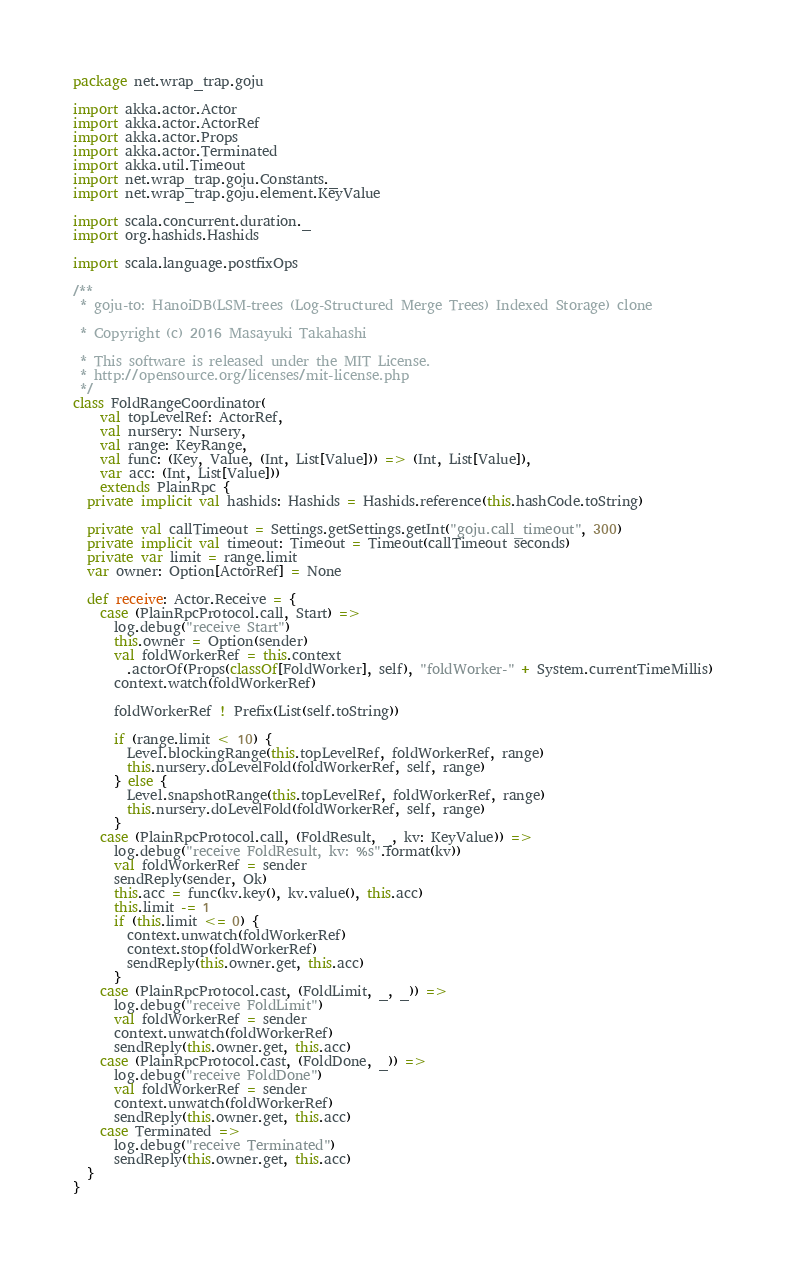<code> <loc_0><loc_0><loc_500><loc_500><_Scala_>package net.wrap_trap.goju

import akka.actor.Actor
import akka.actor.ActorRef
import akka.actor.Props
import akka.actor.Terminated
import akka.util.Timeout
import net.wrap_trap.goju.Constants._
import net.wrap_trap.goju.element.KeyValue

import scala.concurrent.duration._
import org.hashids.Hashids

import scala.language.postfixOps

/**
 * goju-to: HanoiDB(LSM-trees (Log-Structured Merge Trees) Indexed Storage) clone

 * Copyright (c) 2016 Masayuki Takahashi

 * This software is released under the MIT License.
 * http://opensource.org/licenses/mit-license.php
 */
class FoldRangeCoordinator(
    val topLevelRef: ActorRef,
    val nursery: Nursery,
    val range: KeyRange,
    val func: (Key, Value, (Int, List[Value])) => (Int, List[Value]),
    var acc: (Int, List[Value]))
    extends PlainRpc {
  private implicit val hashids: Hashids = Hashids.reference(this.hashCode.toString)

  private val callTimeout = Settings.getSettings.getInt("goju.call_timeout", 300)
  private implicit val timeout: Timeout = Timeout(callTimeout seconds)
  private var limit = range.limit
  var owner: Option[ActorRef] = None

  def receive: Actor.Receive = {
    case (PlainRpcProtocol.call, Start) =>
      log.debug("receive Start")
      this.owner = Option(sender)
      val foldWorkerRef = this.context
        .actorOf(Props(classOf[FoldWorker], self), "foldWorker-" + System.currentTimeMillis)
      context.watch(foldWorkerRef)

      foldWorkerRef ! Prefix(List(self.toString))

      if (range.limit < 10) {
        Level.blockingRange(this.topLevelRef, foldWorkerRef, range)
        this.nursery.doLevelFold(foldWorkerRef, self, range)
      } else {
        Level.snapshotRange(this.topLevelRef, foldWorkerRef, range)
        this.nursery.doLevelFold(foldWorkerRef, self, range)
      }
    case (PlainRpcProtocol.call, (FoldResult, _, kv: KeyValue)) =>
      log.debug("receive FoldResult, kv: %s".format(kv))
      val foldWorkerRef = sender
      sendReply(sender, Ok)
      this.acc = func(kv.key(), kv.value(), this.acc)
      this.limit -= 1
      if (this.limit <= 0) {
        context.unwatch(foldWorkerRef)
        context.stop(foldWorkerRef)
        sendReply(this.owner.get, this.acc)
      }
    case (PlainRpcProtocol.cast, (FoldLimit, _, _)) =>
      log.debug("receive FoldLimit")
      val foldWorkerRef = sender
      context.unwatch(foldWorkerRef)
      sendReply(this.owner.get, this.acc)
    case (PlainRpcProtocol.cast, (FoldDone, _)) =>
      log.debug("receive FoldDone")
      val foldWorkerRef = sender
      context.unwatch(foldWorkerRef)
      sendReply(this.owner.get, this.acc)
    case Terminated =>
      log.debug("receive Terminated")
      sendReply(this.owner.get, this.acc)
  }
}
</code> 